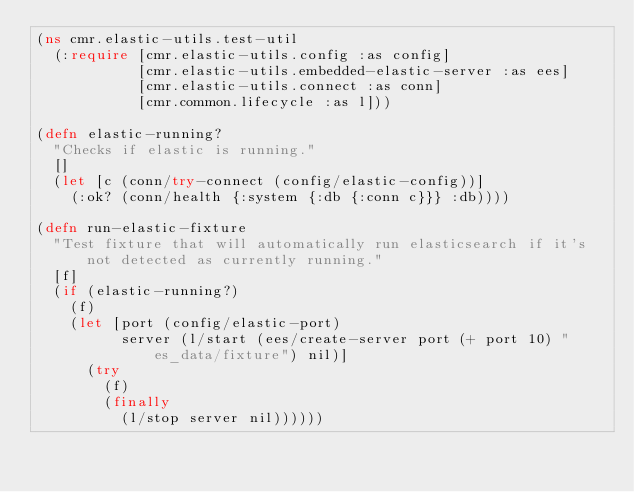<code> <loc_0><loc_0><loc_500><loc_500><_Clojure_>(ns cmr.elastic-utils.test-util
  (:require [cmr.elastic-utils.config :as config]
            [cmr.elastic-utils.embedded-elastic-server :as ees]
            [cmr.elastic-utils.connect :as conn]
            [cmr.common.lifecycle :as l]))

(defn elastic-running?
  "Checks if elastic is running."
  []
  (let [c (conn/try-connect (config/elastic-config))]
    (:ok? (conn/health {:system {:db {:conn c}}} :db))))

(defn run-elastic-fixture
  "Test fixture that will automatically run elasticsearch if it's not detected as currently running."
  [f]
  (if (elastic-running?)
    (f)
    (let [port (config/elastic-port)
          server (l/start (ees/create-server port (+ port 10) "es_data/fixture") nil)]
      (try
        (f)
        (finally
          (l/stop server nil))))))

</code> 